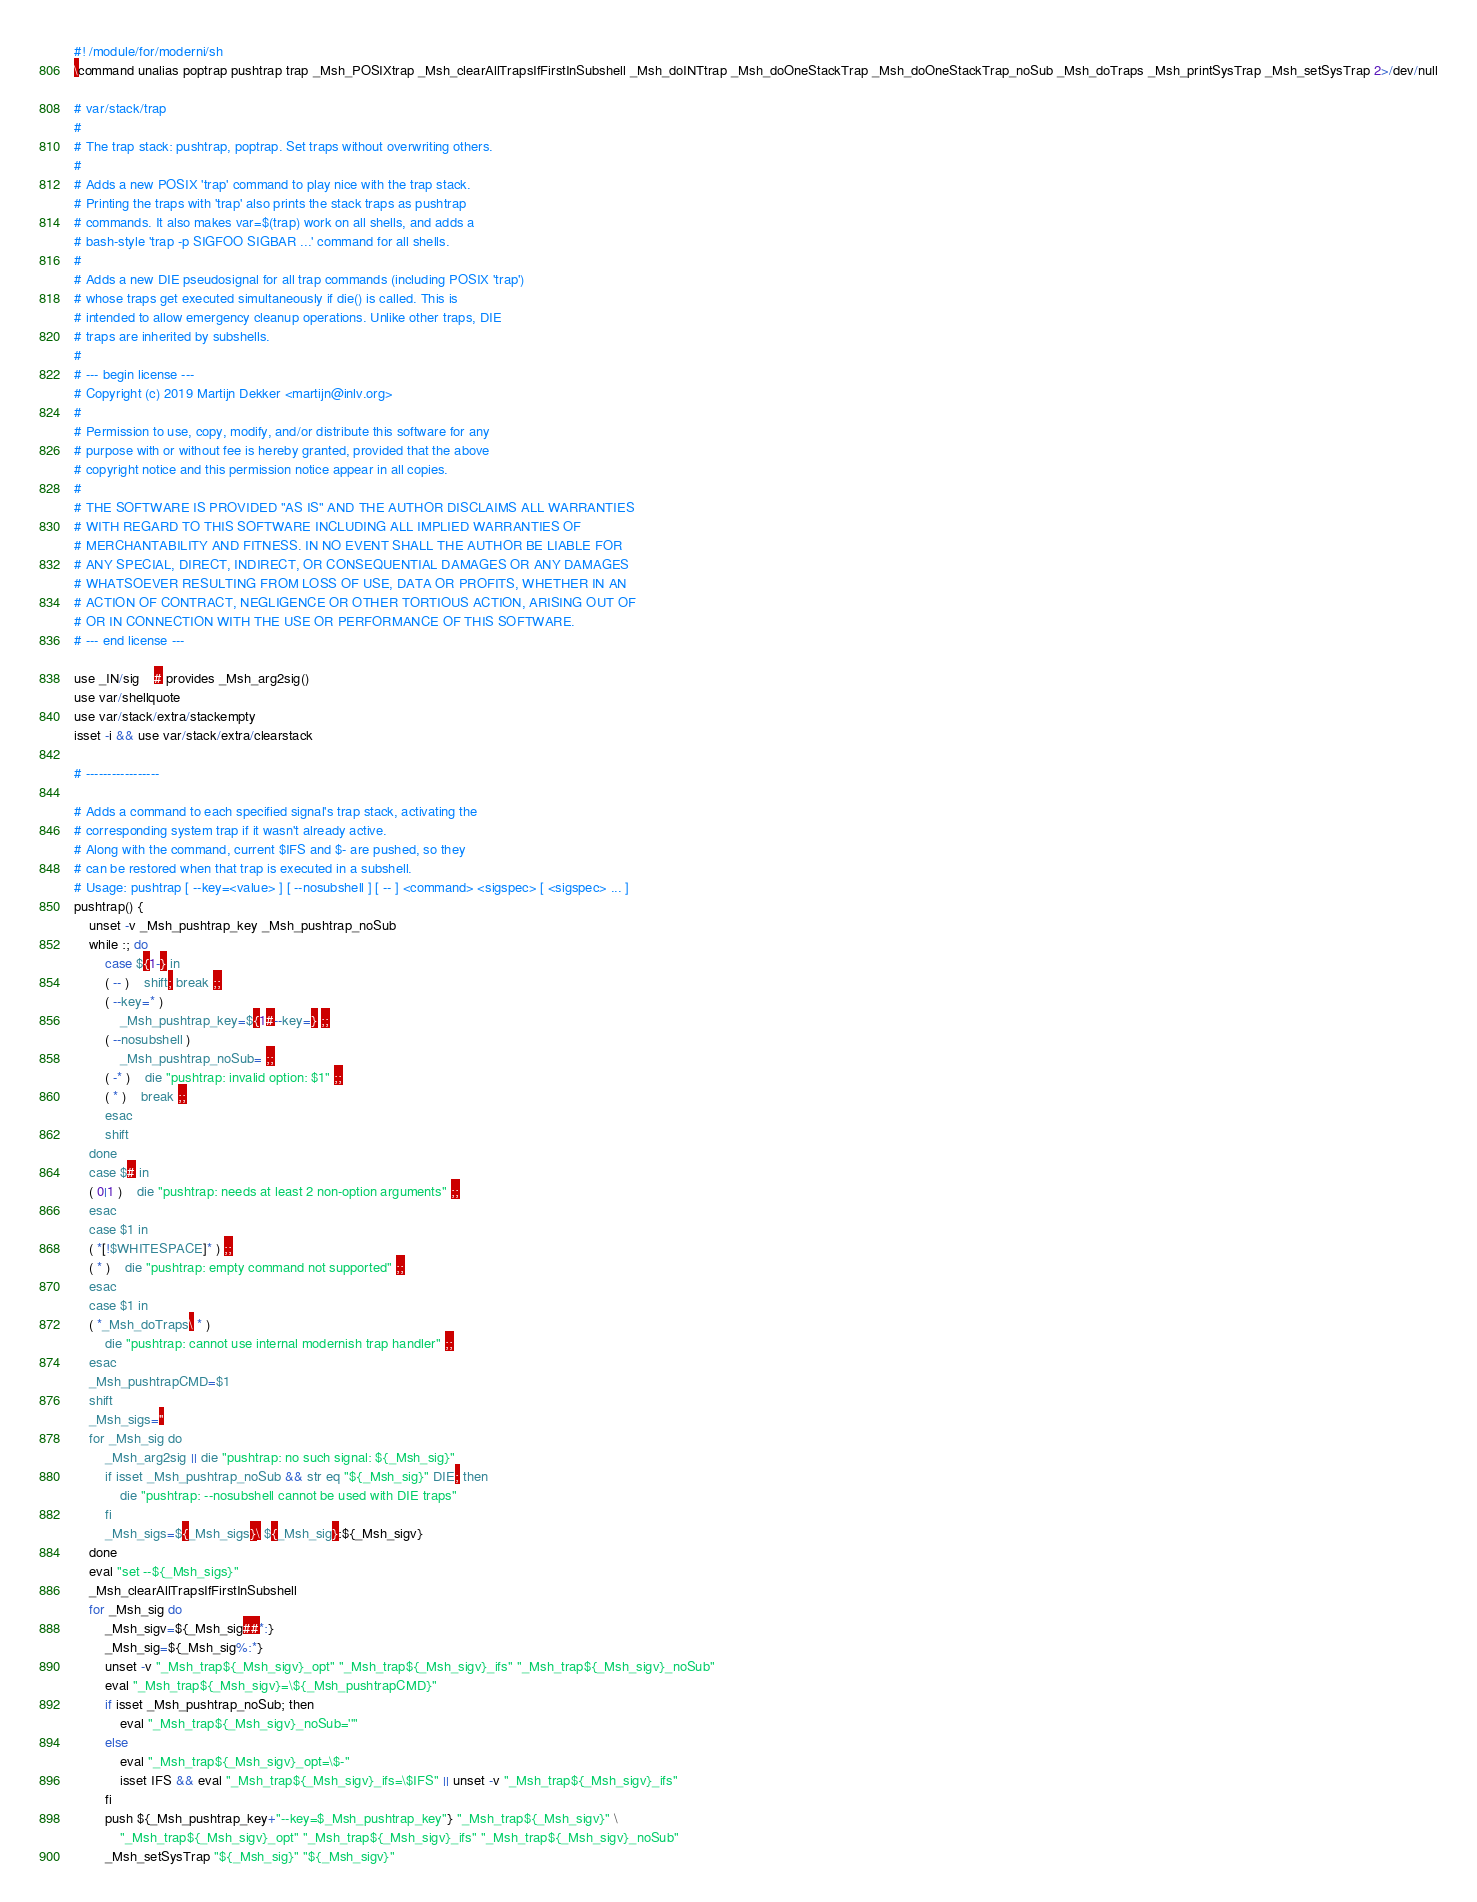<code> <loc_0><loc_0><loc_500><loc_500><_ObjectiveC_>#! /module/for/moderni/sh
\command unalias poptrap pushtrap trap _Msh_POSIXtrap _Msh_clearAllTrapsIfFirstInSubshell _Msh_doINTtrap _Msh_doOneStackTrap _Msh_doOneStackTrap_noSub _Msh_doTraps _Msh_printSysTrap _Msh_setSysTrap 2>/dev/null

# var/stack/trap
#
# The trap stack: pushtrap, poptrap. Set traps without overwriting others.
#
# Adds a new POSIX 'trap' command to play nice with the trap stack.
# Printing the traps with 'trap' also prints the stack traps as pushtrap
# commands. It also makes var=$(trap) work on all shells, and adds a
# bash-style 'trap -p SIGFOO SIGBAR ...' command for all shells.
#
# Adds a new DIE pseudosignal for all trap commands (including POSIX 'trap')
# whose traps get executed simultaneously if die() is called. This is
# intended to allow emergency cleanup operations. Unlike other traps, DIE
# traps are inherited by subshells.
#
# --- begin license ---
# Copyright (c) 2019 Martijn Dekker <martijn@inlv.org>
#
# Permission to use, copy, modify, and/or distribute this software for any
# purpose with or without fee is hereby granted, provided that the above
# copyright notice and this permission notice appear in all copies.
#
# THE SOFTWARE IS PROVIDED "AS IS" AND THE AUTHOR DISCLAIMS ALL WARRANTIES
# WITH REGARD TO THIS SOFTWARE INCLUDING ALL IMPLIED WARRANTIES OF
# MERCHANTABILITY AND FITNESS. IN NO EVENT SHALL THE AUTHOR BE LIABLE FOR
# ANY SPECIAL, DIRECT, INDIRECT, OR CONSEQUENTIAL DAMAGES OR ANY DAMAGES
# WHATSOEVER RESULTING FROM LOSS OF USE, DATA OR PROFITS, WHETHER IN AN
# ACTION OF CONTRACT, NEGLIGENCE OR OTHER TORTIOUS ACTION, ARISING OUT OF
# OR IN CONNECTION WITH THE USE OR PERFORMANCE OF THIS SOFTWARE.
# --- end license ---

use _IN/sig	# provides _Msh_arg2sig()
use var/shellquote
use var/stack/extra/stackempty
isset -i && use var/stack/extra/clearstack

# -----------------

# Adds a command to each specified signal's trap stack, activating the
# corresponding system trap if it wasn't already active.
# Along with the command, current $IFS and $- are pushed, so they
# can be restored when that trap is executed in a subshell.
# Usage: pushtrap [ --key=<value> ] [ --nosubshell ] [ -- ] <command> <sigspec> [ <sigspec> ... ]
pushtrap() {
	unset -v _Msh_pushtrap_key _Msh_pushtrap_noSub
	while :; do
		case ${1-} in
		( -- )	shift; break ;;
		( --key=* )
			_Msh_pushtrap_key=${1#--key=} ;;
		( --nosubshell )
			_Msh_pushtrap_noSub= ;;
		( -* )	die "pushtrap: invalid option: $1" ;;
		( * )	break ;;
		esac
		shift
	done
	case $# in
	( 0|1 )	die "pushtrap: needs at least 2 non-option arguments" ;;
	esac
	case $1 in
	( *[!$WHITESPACE]* ) ;;
	( * )	die "pushtrap: empty command not supported" ;;
	esac
	case $1 in
	( *_Msh_doTraps\ * )
		die "pushtrap: cannot use internal modernish trap handler" ;;
	esac
	_Msh_pushtrapCMD=$1
	shift
	_Msh_sigs=''
	for _Msh_sig do
		_Msh_arg2sig || die "pushtrap: no such signal: ${_Msh_sig}"
		if isset _Msh_pushtrap_noSub && str eq "${_Msh_sig}" DIE; then
			die "pushtrap: --nosubshell cannot be used with DIE traps"
		fi
		_Msh_sigs=${_Msh_sigs}\ ${_Msh_sig}:${_Msh_sigv}
	done
	eval "set --${_Msh_sigs}"
	_Msh_clearAllTrapsIfFirstInSubshell
	for _Msh_sig do
		_Msh_sigv=${_Msh_sig##*:}
		_Msh_sig=${_Msh_sig%:*}
		unset -v "_Msh_trap${_Msh_sigv}_opt" "_Msh_trap${_Msh_sigv}_ifs" "_Msh_trap${_Msh_sigv}_noSub"
		eval "_Msh_trap${_Msh_sigv}=\${_Msh_pushtrapCMD}"
		if isset _Msh_pushtrap_noSub; then
			eval "_Msh_trap${_Msh_sigv}_noSub=''"
		else
			eval "_Msh_trap${_Msh_sigv}_opt=\$-"
			isset IFS && eval "_Msh_trap${_Msh_sigv}_ifs=\$IFS" || unset -v "_Msh_trap${_Msh_sigv}_ifs"
		fi
		push ${_Msh_pushtrap_key+"--key=$_Msh_pushtrap_key"} "_Msh_trap${_Msh_sigv}" \
			"_Msh_trap${_Msh_sigv}_opt" "_Msh_trap${_Msh_sigv}_ifs" "_Msh_trap${_Msh_sigv}_noSub"
		_Msh_setSysTrap "${_Msh_sig}" "${_Msh_sigv}"</code> 